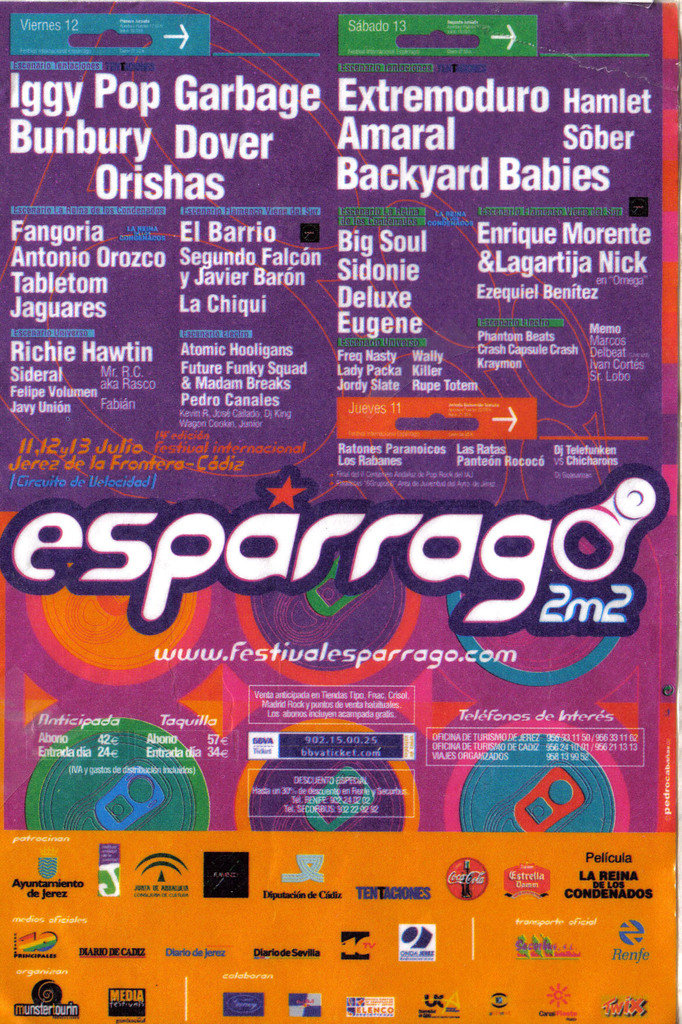Who are the main performers highlighted in this poster and what dates are associated with their performances? The main performers highlighted on the poster for Friday, July 12, include Iggy Pop, Garbage, Orishas, and others. For Saturday, July 13, some of the prominent names are Extremoduro, Amaral, and Sôber. The image meticulously arranges these performers under their respective dates. 